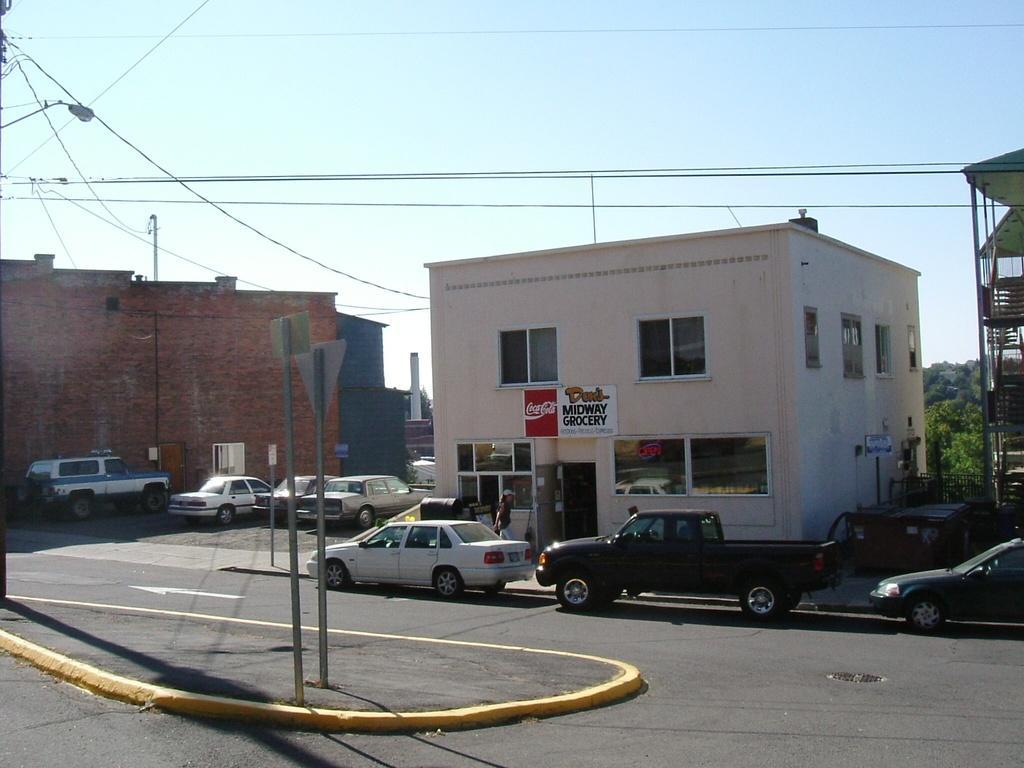Describe this image in one or two sentences. In this picture we can observe a road on which some cars moving. There are some buildings. We can observe some cars parked in between the two buildings. There are two poles on the road. We can observe some wires. In the background there are trees and a sky. 